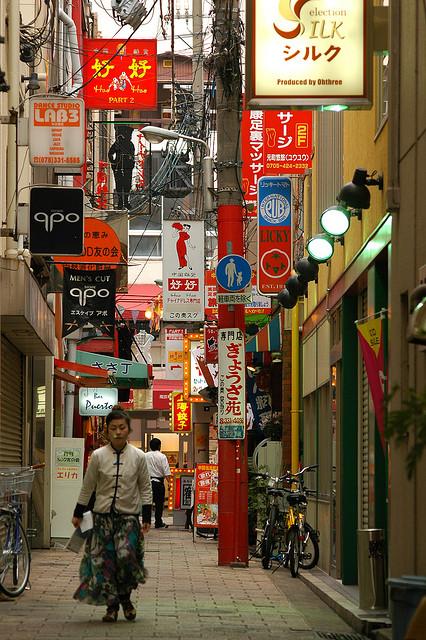How many signs are black?
Keep it brief. 2. How many bikes in this photo?
Give a very brief answer. 3. Is this an American shopping mall?
Answer briefly. No. 